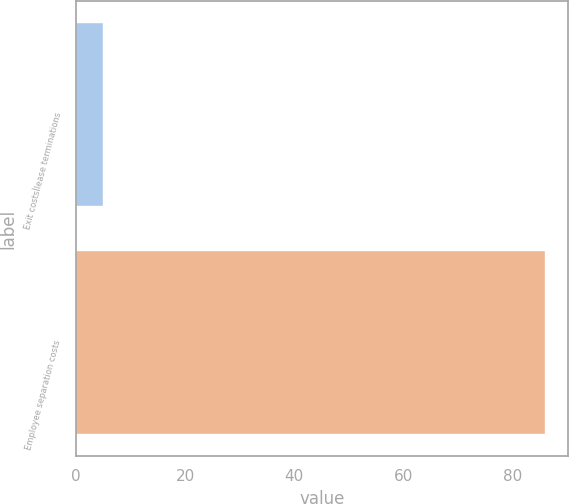Convert chart. <chart><loc_0><loc_0><loc_500><loc_500><bar_chart><fcel>Exit costsÌlease terminations<fcel>Employee separation costs<nl><fcel>5<fcel>86<nl></chart> 